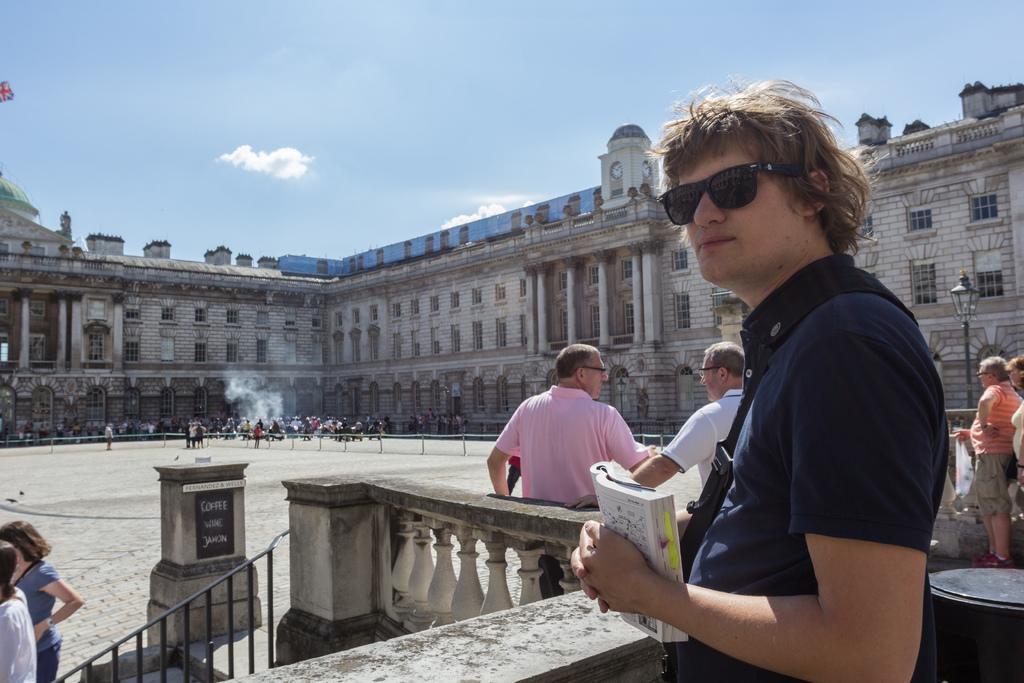How would you summarize this image in a sentence or two? In the picture I can see people are standing on the ground among them the man in the front is holding an object in hands and wearing black color shades. In the background I can see a building, smoke, pole lights, the sky and some other objects. 